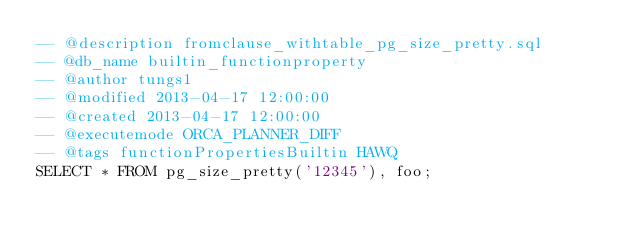<code> <loc_0><loc_0><loc_500><loc_500><_SQL_>-- @description fromclause_withtable_pg_size_pretty.sql
-- @db_name builtin_functionproperty
-- @author tungs1
-- @modified 2013-04-17 12:00:00
-- @created 2013-04-17 12:00:00
-- @executemode ORCA_PLANNER_DIFF
-- @tags functionPropertiesBuiltin HAWQ
SELECT * FROM pg_size_pretty('12345'), foo;
</code> 